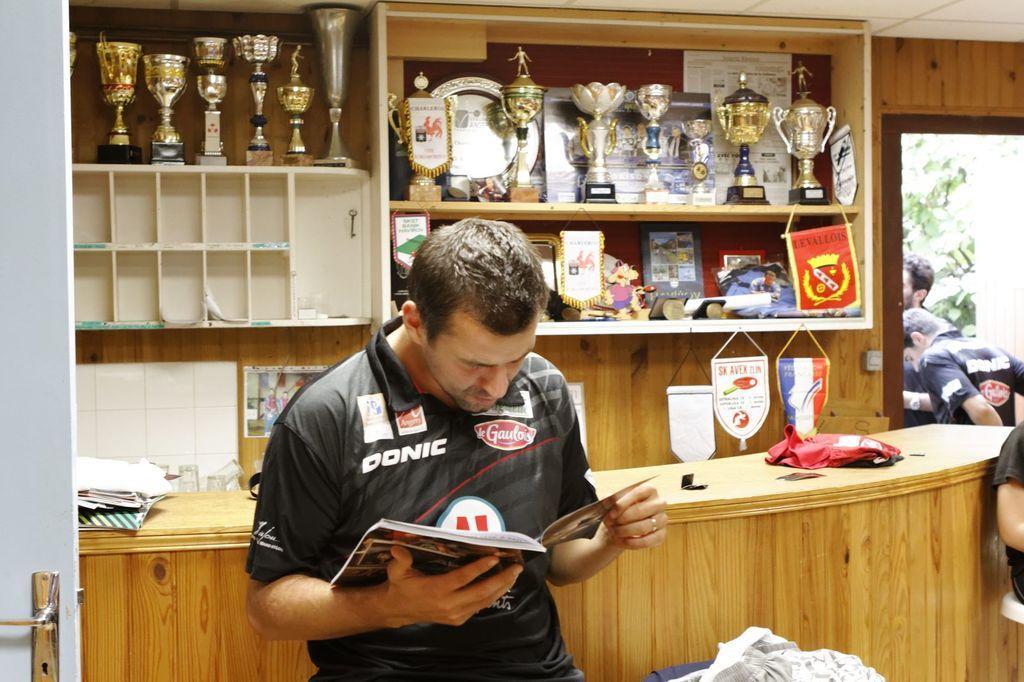Could you give a brief overview of what you see in this image? In this image we can see persons standing on the floor and sitting on the chairs and one of them is holding a book in the hands. In the background there are mementos and some objects arranged in the cupboards. 